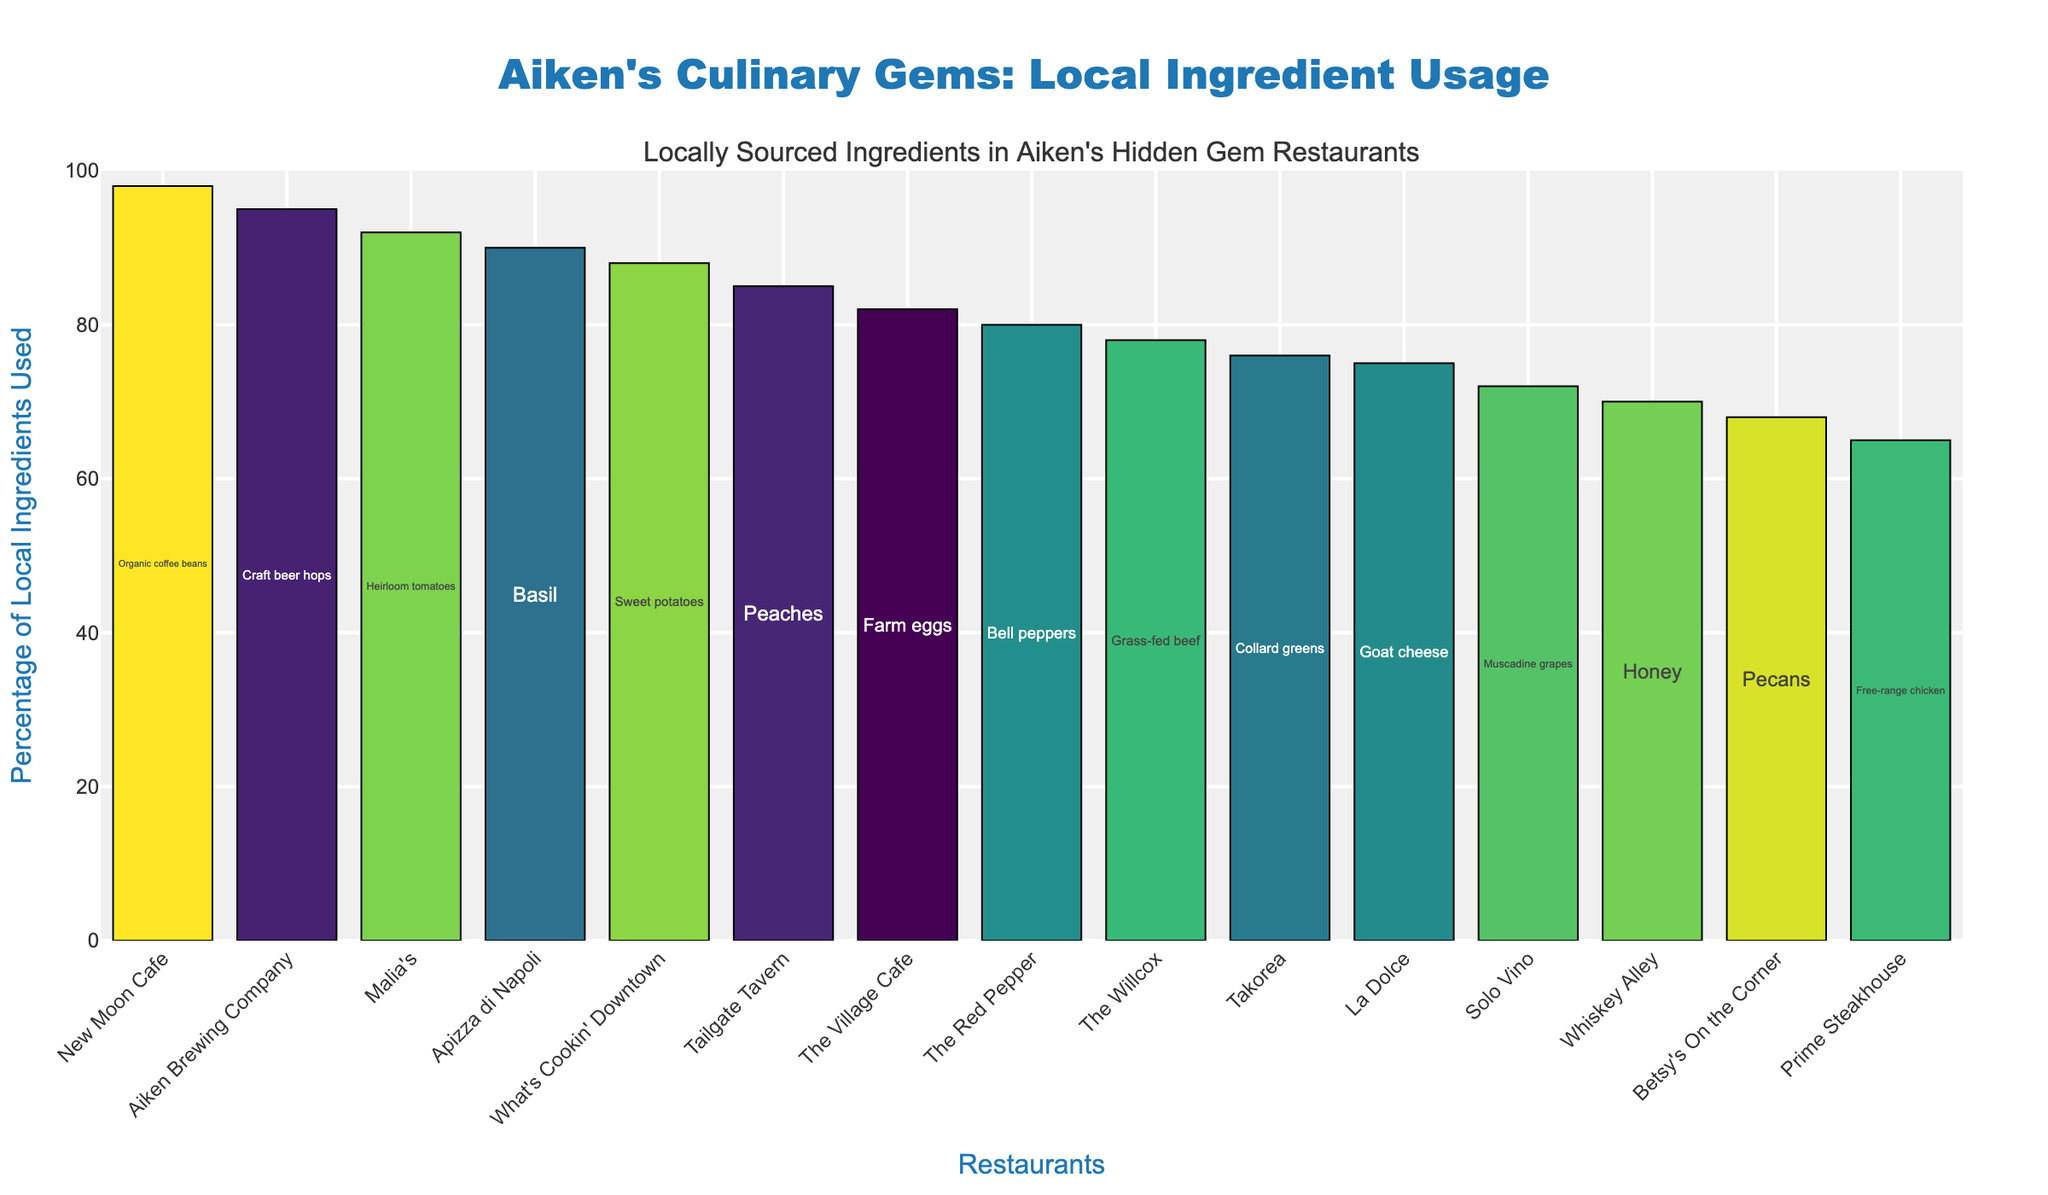What's the highest percentage of locally sourced ingredients used among these restaurants? Look at the bar chart and identify which bar reaches the highest point on the y-axis. The text inside the bar will confirm the percentage.
Answer: 98% Which restaurant uses locally sourced basil, and what percentage do they use? Locate the bar with the text "Basil" inside it, and note the restaurant name and the percentage from the y-axis value.
Answer: Apizza di Napoli, 90% How many restaurants use more than 80% of locally sourced ingredients? Count the number of bars that extend beyond the 80% mark on the y-axis.
Answer: 7 Which restaurant uses the least percentage of locally sourced ingredients and what is that percentage? Identify the shortest bar on the chart and read the percentage from the y-axis and the restaurant name.
Answer: Prime Steakhouse, 65% What is the average percentage of locally sourced ingredients used by "Solo Vino" and "The Village Cafe"? Locate the bars for "Solo Vino" and "The Village Cafe", sum their percentages, and divide by 2. (72 + 82) / 2 = 77
Answer: 77 Compare the usage of locally sourced grass-fed beef and heirloom tomatoes. Which restaurant uses a higher percentage, and by how much? Locate the bars for "Grass-fed beef" and "Heirloom tomatoes", and subtract the lower percentage from the higher one. (92 - 78) = 14
Answer: Malia's uses 14% more What's the total percentage sum for the top three restaurants with the highest usage of locally sourced ingredients? Identify the top three bars, sum their percentages: 98 + 95 + 92 = 285
Answer: 285 Which ingredient is used by "Tailgate Tavern," and how does it compare to the percentage used by "La Dolce"? Find the bars for "Tailgate Tavern" (Peaches, 85%) and "La Dolce" (Goat cheese, 75%), then subtract the lower percentage from the higher one. (85 - 75) = 10
Answer: Peaches by Tailgate Tavern is used 10% more What is the median percentage of locally sourced ingredients used by these 15 restaurants? Arrange the percentages in ascending order and find the middle value. The sorted percentages are [65, 68, 70, 72, 75, 76, 78, 80, 82, 85, 88, 90, 92, 95, 98], so the median value is 80.
Answer: 80 Which restaurant uses local craft beer hops, and is it above or below the average usage percentage for all restaurants? Locate the bar with the text "Craft beer hops" (Aiken Brewing Company, 95%). Calculate the average percentage: (Sum of all percentages) / 15 = 1296 / 15 = 86.4, and compare.
Answer: Aiken Brewing Company, above the average 